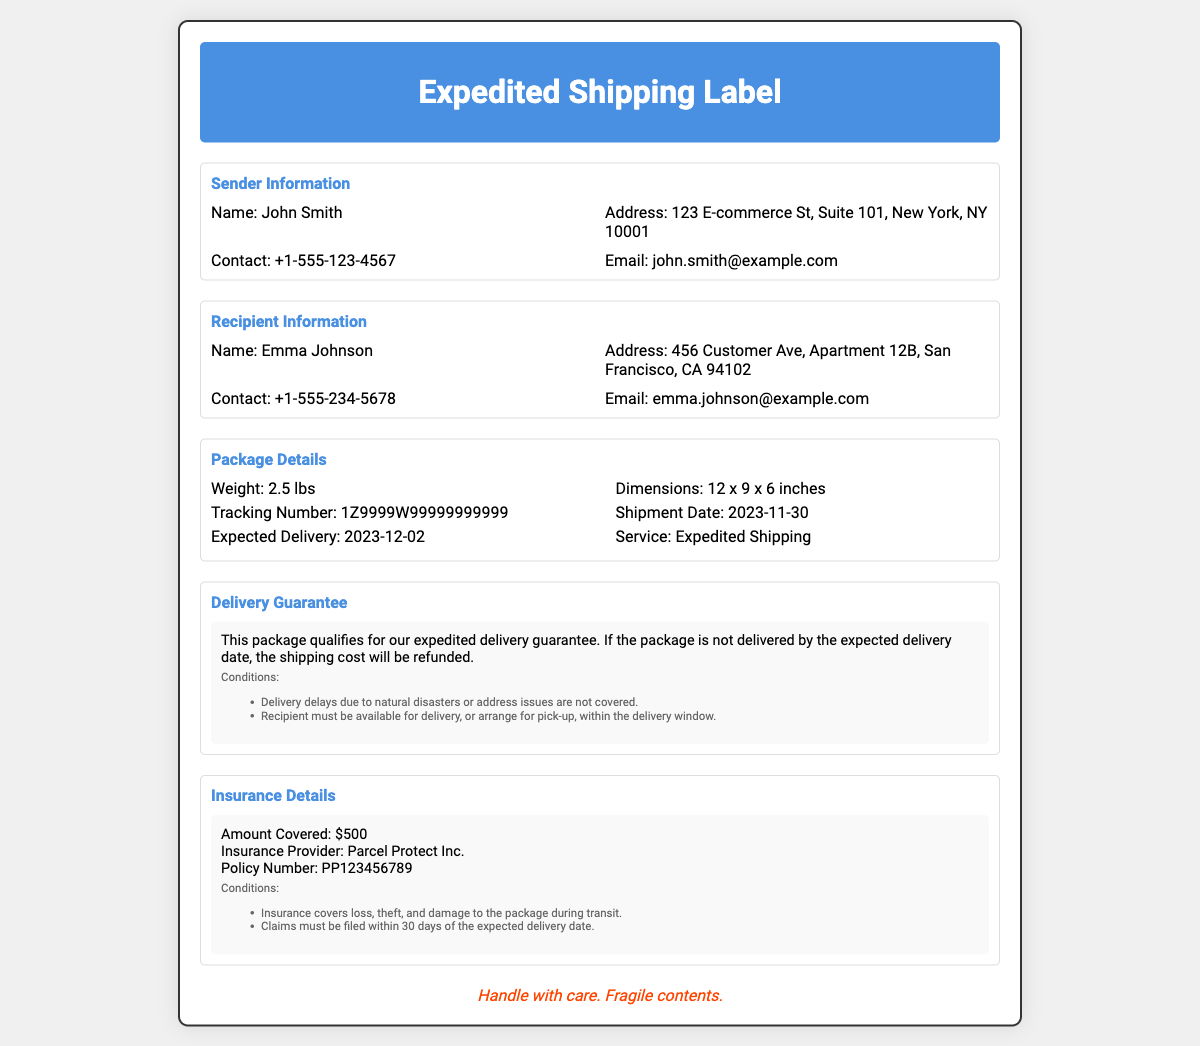What is the weight of the package? The package's weight is listed in the Package Details section of the document.
Answer: 2.5 lbs When is the expected delivery date? The expected delivery date is mentioned in the Package Details section of the document.
Answer: 2023-12-02 What is the amount covered by the insurance? The insurance coverage amount is specified in the Insurance Details section of the document.
Answer: $500 What is the insurance provider's name? The insurance provider's name is provided in the Insurance Details section of the document.
Answer: Parcel Protect Inc What are the conditions for delivery guarantee? The conditions for the delivery guarantee are noted in the Delivery Guarantee section of the document.
Answer: Delivery delays due to natural disasters or address issues are not covered and Recipient must be available for delivery, or arrange for pick-up, within the delivery window What is the tracking number? The tracking number can be found in the Package Details section of the document.
Answer: 1Z9999W99999999999 What should you do if the package is not delivered on time? The information on what to do if the package is late is mentioned in the Delivery Guarantee section of the document.
Answer: The shipping cost will be refunded 